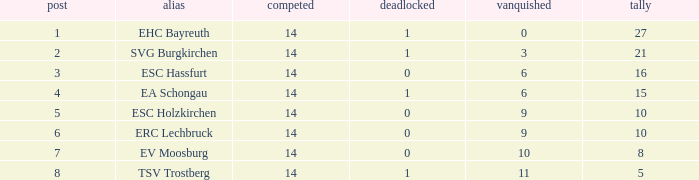What's the most points for Ea Schongau with more than 1 drawn? None. 